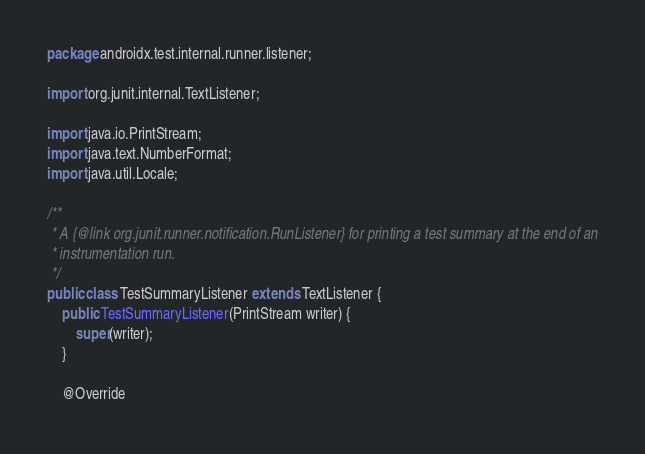<code> <loc_0><loc_0><loc_500><loc_500><_Java_>package androidx.test.internal.runner.listener;

import org.junit.internal.TextListener;

import java.io.PrintStream;
import java.text.NumberFormat;
import java.util.Locale;

/**
 * A {@link org.junit.runner.notification.RunListener} for printing a test summary at the end of an
 * instrumentation run.
 */
public class TestSummaryListener extends TextListener {
    public TestSummaryListener(PrintStream writer) {
        super(writer);
    }

    @Override</code> 